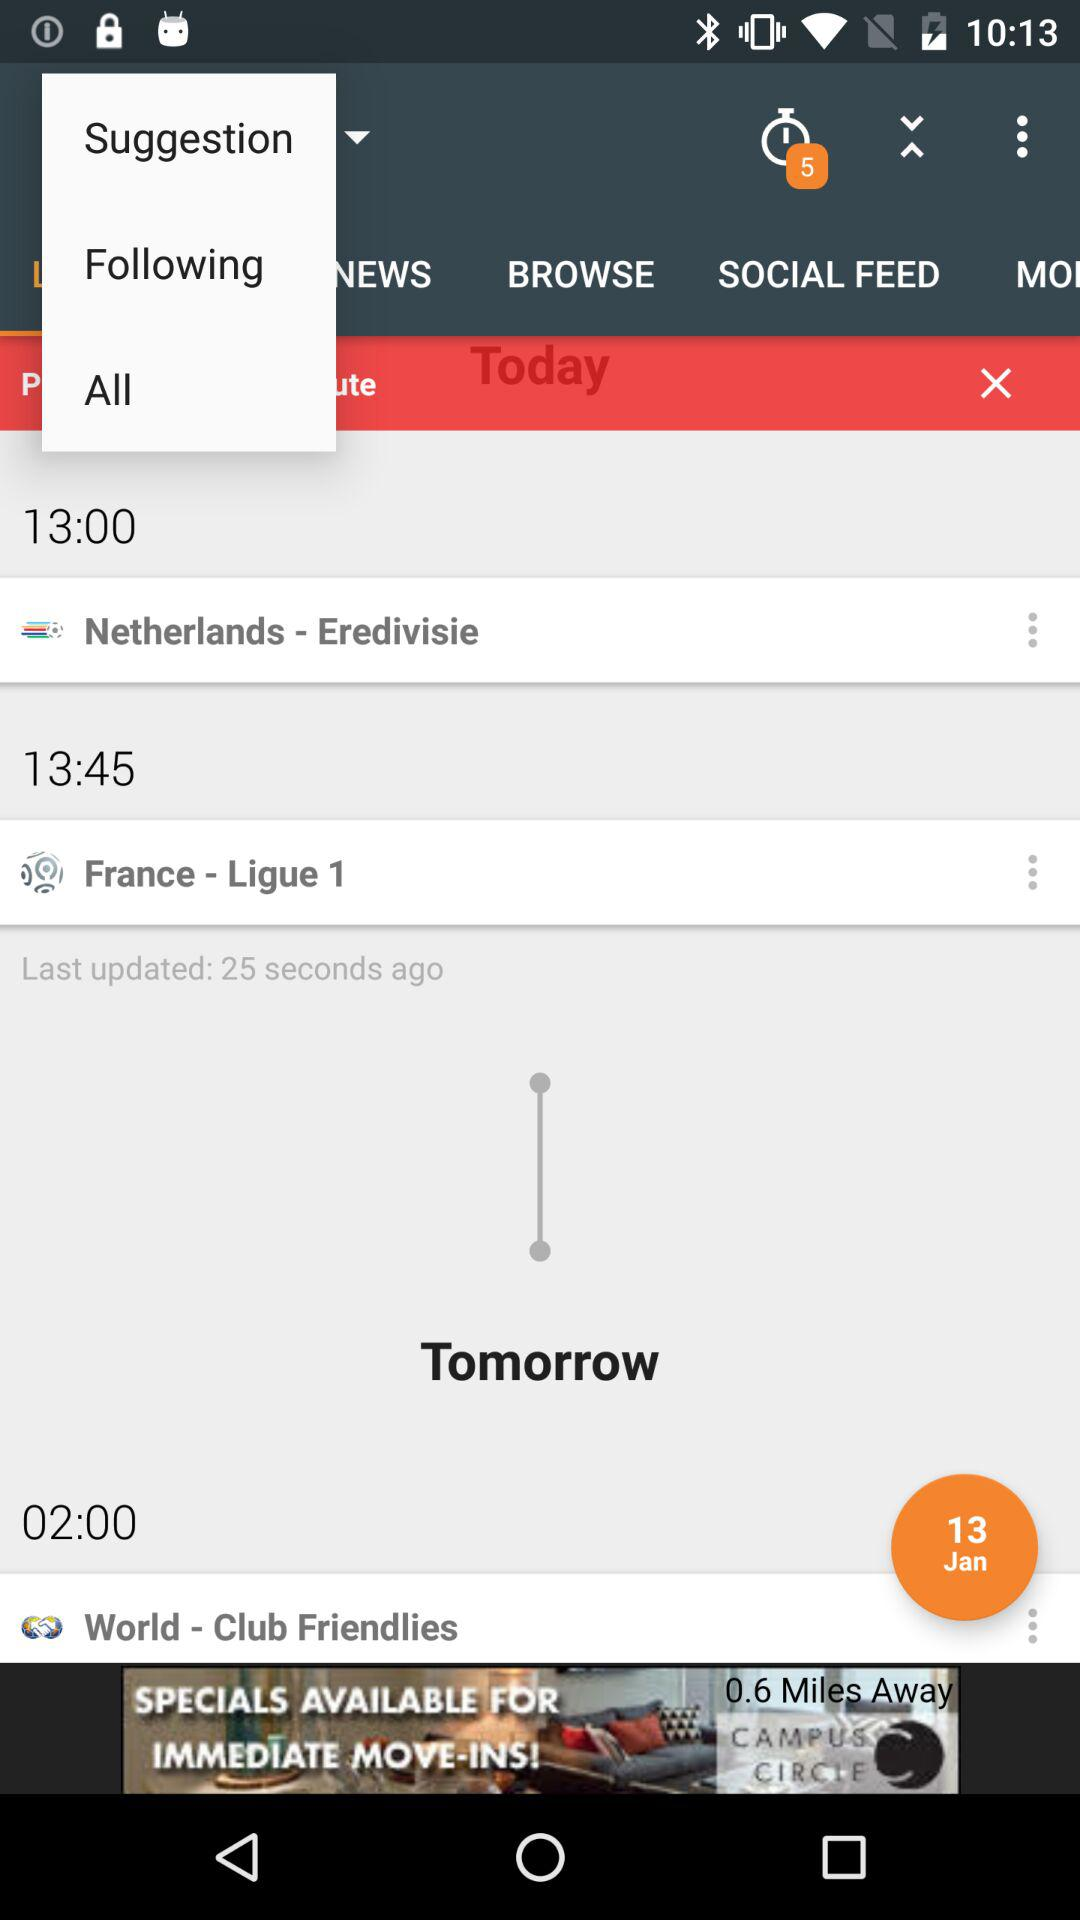What is the time for last updation? The last updated time is 13:45. 